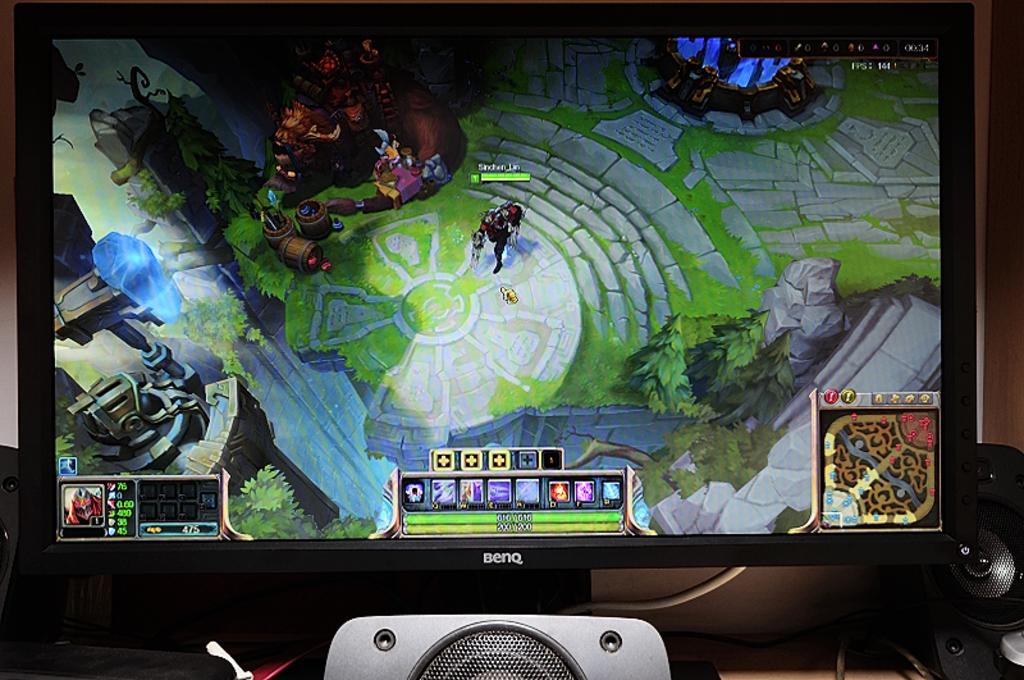<image>
Render a clear and concise summary of the photo. a screen of a video game, the characters user name has an underscore 